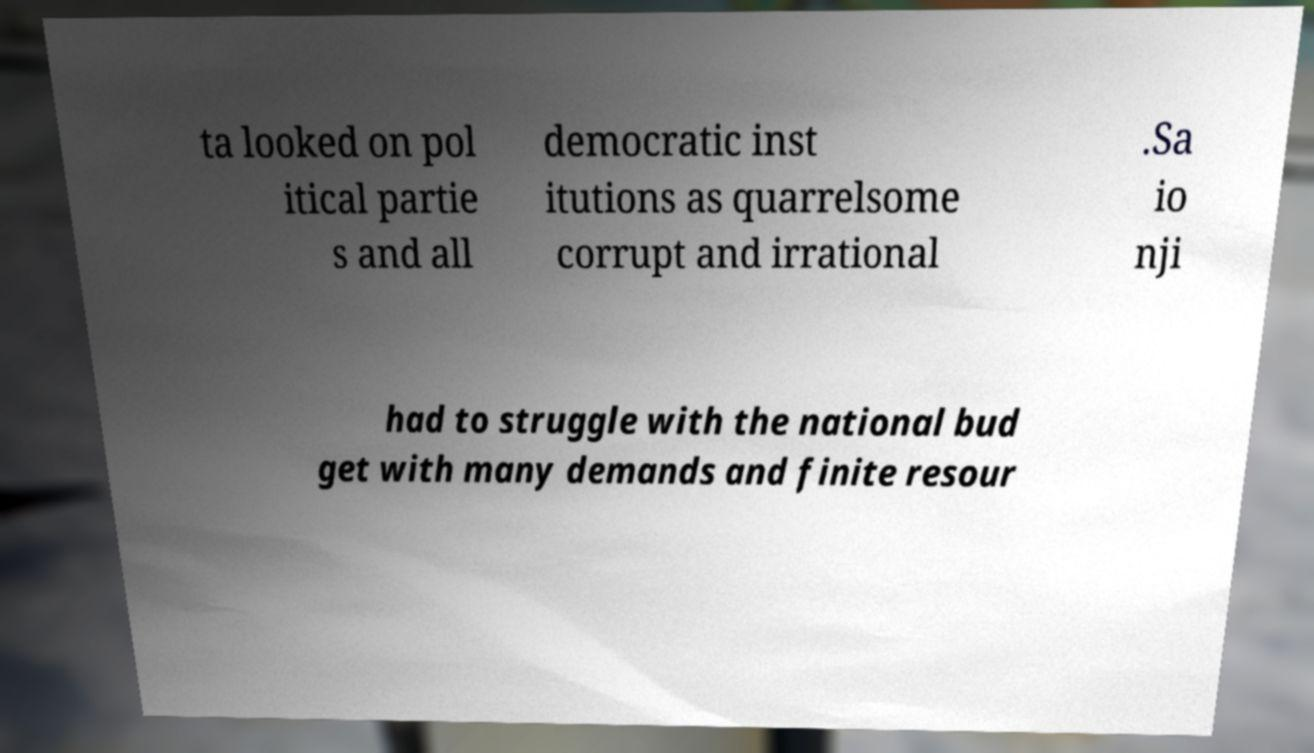Could you assist in decoding the text presented in this image and type it out clearly? ta looked on pol itical partie s and all democratic inst itutions as quarrelsome corrupt and irrational .Sa io nji had to struggle with the national bud get with many demands and finite resour 